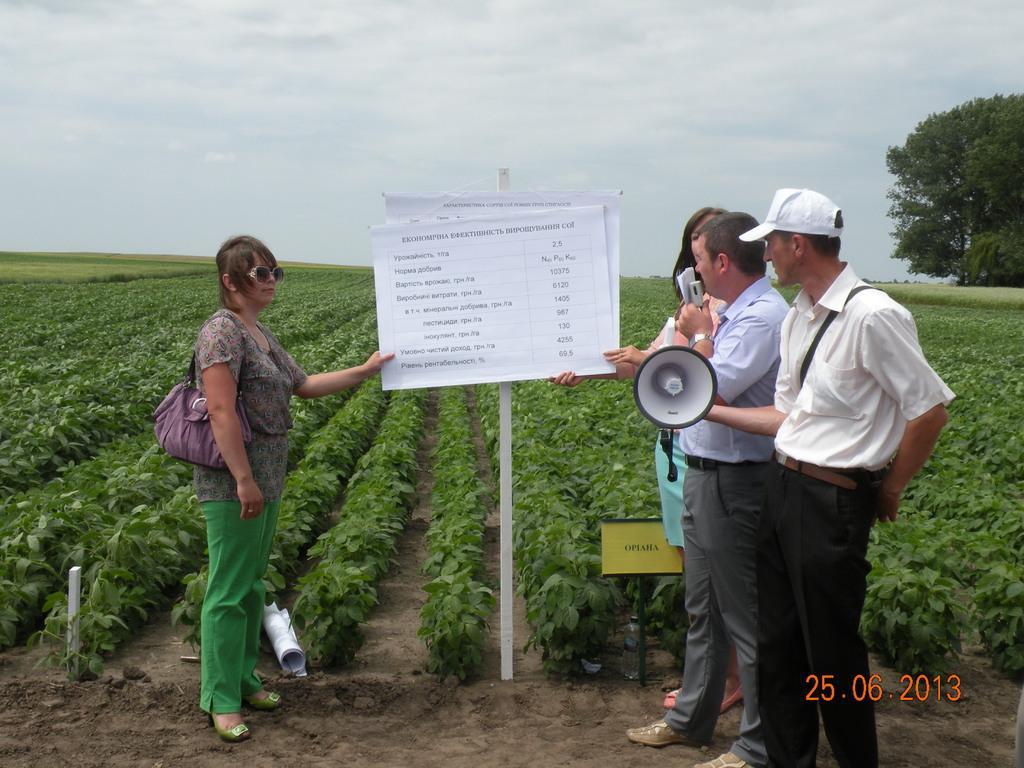How would you summarize this image in a sentence or two? In this image I can see four persons are standing on the ground and are holding objects in their hand, posters, pole, and plants. In the background I can see trees and the sky. This image is taken may be in a farm. 